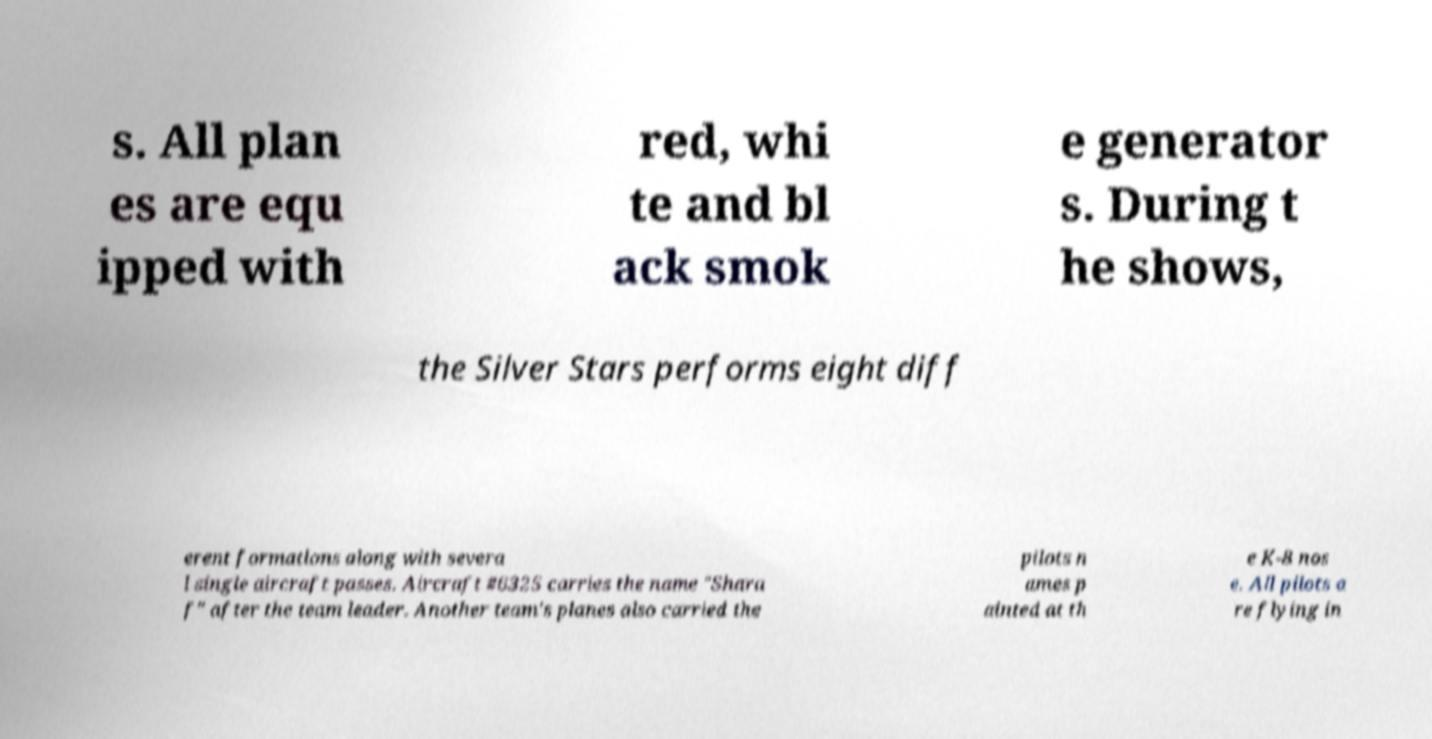Please identify and transcribe the text found in this image. s. All plan es are equ ipped with red, whi te and bl ack smok e generator s. During t he shows, the Silver Stars performs eight diff erent formations along with severa l single aircraft passes. Aircraft #6325 carries the name "Shara f" after the team leader. Another team's planes also carried the pilots n ames p ainted at th e K-8 nos e. All pilots a re flying in 